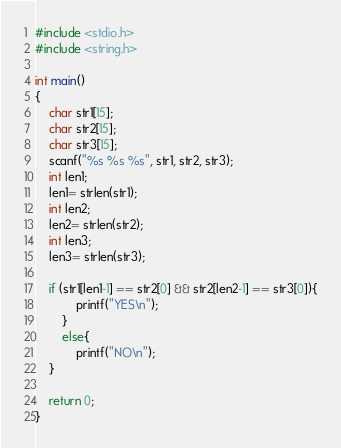Convert code to text. <code><loc_0><loc_0><loc_500><loc_500><_C++_>#include <stdio.h>
#include <string.h>

int main()
{
	char str1[15];
	char str2[15];
	char str3[15];
	scanf("%s %s %s", str1, str2, str3);
	int len1;
	len1= strlen(str1);
	int len2;
	len2= strlen(str2);
	int len3;
	len3= strlen(str3);
	
	if (str1[len1-1] == str2[0] && str2[len2-1] == str3[0]){
			printf("YES\n");
		}
		else{
			printf("NO\n");
	}
		
	return 0;
}</code> 